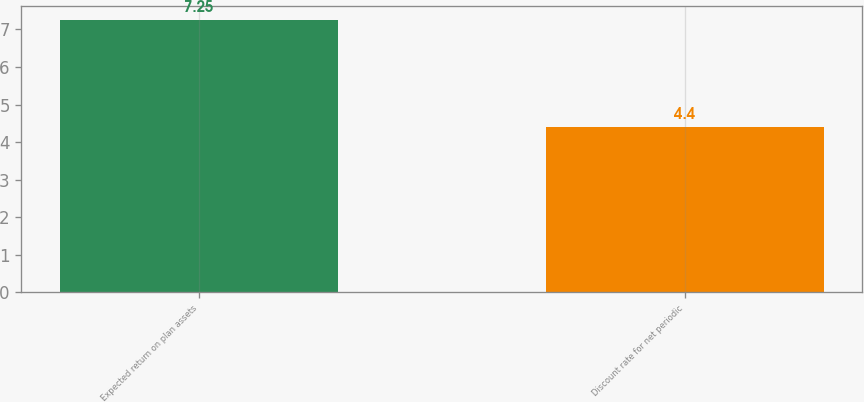Convert chart. <chart><loc_0><loc_0><loc_500><loc_500><bar_chart><fcel>Expected return on plan assets<fcel>Discount rate for net periodic<nl><fcel>7.25<fcel>4.4<nl></chart> 